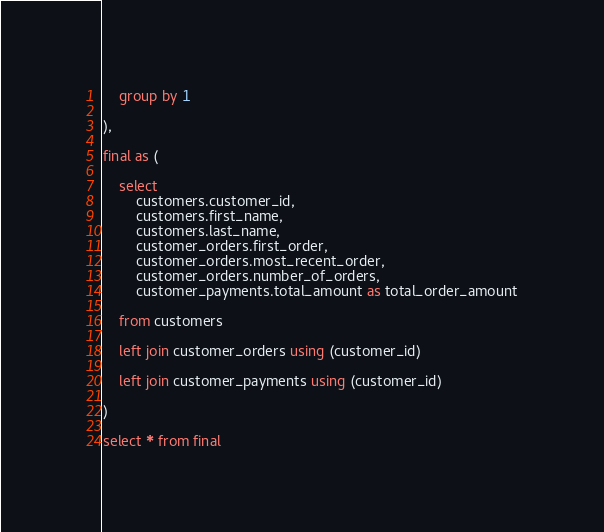<code> <loc_0><loc_0><loc_500><loc_500><_SQL_>    group by 1

),

final as (

    select
        customers.customer_id,
        customers.first_name,
        customers.last_name,
        customer_orders.first_order,
        customer_orders.most_recent_order,
        customer_orders.number_of_orders,
        customer_payments.total_amount as total_order_amount

    from customers

    left join customer_orders using (customer_id)

    left join customer_payments using (customer_id)

)

select * from final
</code> 